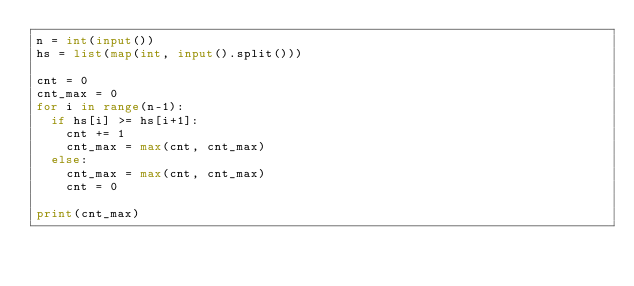<code> <loc_0><loc_0><loc_500><loc_500><_Python_>n = int(input())
hs = list(map(int, input().split()))

cnt = 0
cnt_max = 0
for i in range(n-1):
  if hs[i] >= hs[i+1]:
    cnt += 1
    cnt_max = max(cnt, cnt_max)
  else:
    cnt_max = max(cnt, cnt_max)
    cnt = 0
    
print(cnt_max)</code> 